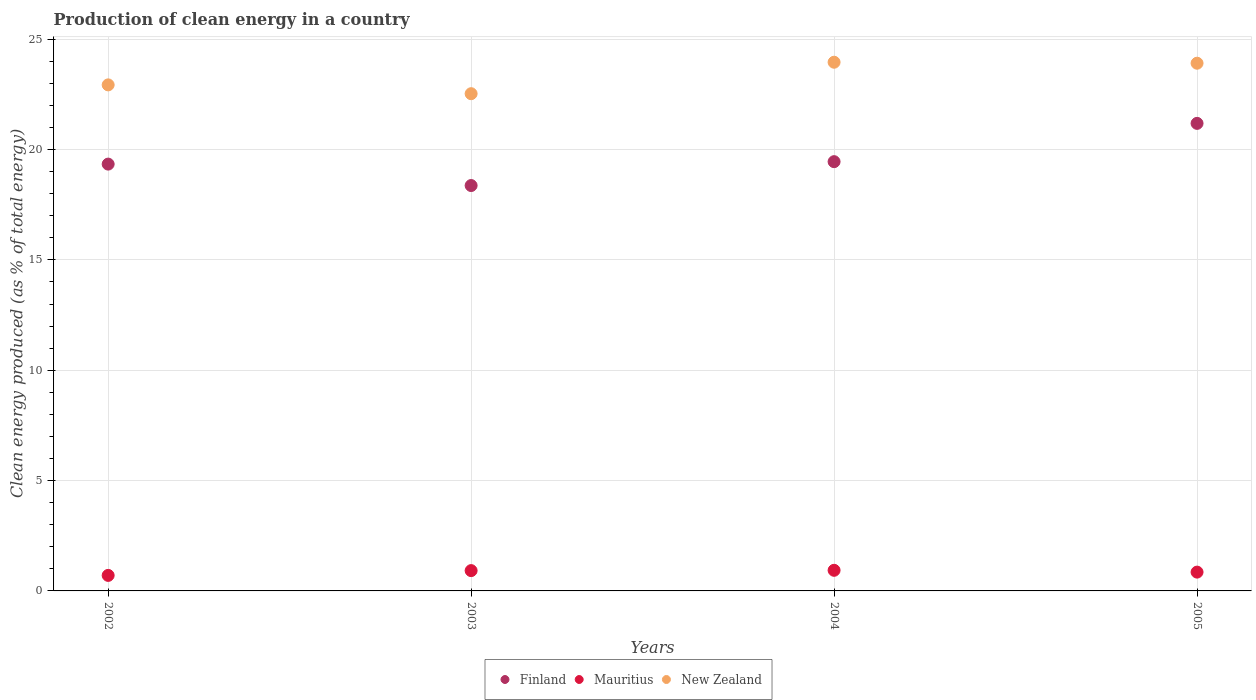How many different coloured dotlines are there?
Your answer should be very brief. 3. Is the number of dotlines equal to the number of legend labels?
Offer a very short reply. Yes. What is the percentage of clean energy produced in New Zealand in 2002?
Keep it short and to the point. 22.93. Across all years, what is the maximum percentage of clean energy produced in Finland?
Your answer should be compact. 21.19. Across all years, what is the minimum percentage of clean energy produced in Finland?
Make the answer very short. 18.37. In which year was the percentage of clean energy produced in Finland minimum?
Offer a very short reply. 2003. What is the total percentage of clean energy produced in Finland in the graph?
Your answer should be very brief. 78.35. What is the difference between the percentage of clean energy produced in New Zealand in 2003 and that in 2004?
Provide a succinct answer. -1.43. What is the difference between the percentage of clean energy produced in Mauritius in 2004 and the percentage of clean energy produced in New Zealand in 2002?
Provide a succinct answer. -22. What is the average percentage of clean energy produced in Finland per year?
Provide a short and direct response. 19.59. In the year 2004, what is the difference between the percentage of clean energy produced in Mauritius and percentage of clean energy produced in New Zealand?
Ensure brevity in your answer.  -23.02. What is the ratio of the percentage of clean energy produced in Finland in 2003 to that in 2005?
Keep it short and to the point. 0.87. Is the difference between the percentage of clean energy produced in Mauritius in 2003 and 2005 greater than the difference between the percentage of clean energy produced in New Zealand in 2003 and 2005?
Provide a succinct answer. Yes. What is the difference between the highest and the second highest percentage of clean energy produced in New Zealand?
Provide a succinct answer. 0.04. What is the difference between the highest and the lowest percentage of clean energy produced in New Zealand?
Your answer should be compact. 1.43. Is the sum of the percentage of clean energy produced in New Zealand in 2002 and 2003 greater than the maximum percentage of clean energy produced in Finland across all years?
Offer a terse response. Yes. Is it the case that in every year, the sum of the percentage of clean energy produced in New Zealand and percentage of clean energy produced in Mauritius  is greater than the percentage of clean energy produced in Finland?
Keep it short and to the point. Yes. Does the percentage of clean energy produced in Finland monotonically increase over the years?
Make the answer very short. No. Is the percentage of clean energy produced in New Zealand strictly greater than the percentage of clean energy produced in Finland over the years?
Keep it short and to the point. Yes. How many years are there in the graph?
Make the answer very short. 4. What is the difference between two consecutive major ticks on the Y-axis?
Your answer should be compact. 5. Where does the legend appear in the graph?
Keep it short and to the point. Bottom center. How are the legend labels stacked?
Offer a very short reply. Horizontal. What is the title of the graph?
Your response must be concise. Production of clean energy in a country. What is the label or title of the Y-axis?
Your response must be concise. Clean energy produced (as % of total energy). What is the Clean energy produced (as % of total energy) of Finland in 2002?
Give a very brief answer. 19.34. What is the Clean energy produced (as % of total energy) in Mauritius in 2002?
Provide a succinct answer. 0.7. What is the Clean energy produced (as % of total energy) in New Zealand in 2002?
Your response must be concise. 22.93. What is the Clean energy produced (as % of total energy) in Finland in 2003?
Your answer should be very brief. 18.37. What is the Clean energy produced (as % of total energy) in Mauritius in 2003?
Offer a terse response. 0.92. What is the Clean energy produced (as % of total energy) of New Zealand in 2003?
Give a very brief answer. 22.53. What is the Clean energy produced (as % of total energy) of Finland in 2004?
Keep it short and to the point. 19.45. What is the Clean energy produced (as % of total energy) in Mauritius in 2004?
Your answer should be compact. 0.93. What is the Clean energy produced (as % of total energy) in New Zealand in 2004?
Offer a very short reply. 23.96. What is the Clean energy produced (as % of total energy) of Finland in 2005?
Your answer should be very brief. 21.19. What is the Clean energy produced (as % of total energy) of Mauritius in 2005?
Your response must be concise. 0.85. What is the Clean energy produced (as % of total energy) of New Zealand in 2005?
Provide a succinct answer. 23.91. Across all years, what is the maximum Clean energy produced (as % of total energy) in Finland?
Offer a terse response. 21.19. Across all years, what is the maximum Clean energy produced (as % of total energy) of Mauritius?
Offer a terse response. 0.93. Across all years, what is the maximum Clean energy produced (as % of total energy) of New Zealand?
Ensure brevity in your answer.  23.96. Across all years, what is the minimum Clean energy produced (as % of total energy) in Finland?
Provide a short and direct response. 18.37. Across all years, what is the minimum Clean energy produced (as % of total energy) of Mauritius?
Your answer should be compact. 0.7. Across all years, what is the minimum Clean energy produced (as % of total energy) of New Zealand?
Ensure brevity in your answer.  22.53. What is the total Clean energy produced (as % of total energy) in Finland in the graph?
Offer a terse response. 78.35. What is the total Clean energy produced (as % of total energy) in Mauritius in the graph?
Give a very brief answer. 3.41. What is the total Clean energy produced (as % of total energy) of New Zealand in the graph?
Provide a short and direct response. 93.33. What is the difference between the Clean energy produced (as % of total energy) in Finland in 2002 and that in 2003?
Make the answer very short. 0.97. What is the difference between the Clean energy produced (as % of total energy) of Mauritius in 2002 and that in 2003?
Offer a very short reply. -0.22. What is the difference between the Clean energy produced (as % of total energy) in New Zealand in 2002 and that in 2003?
Your answer should be very brief. 0.4. What is the difference between the Clean energy produced (as % of total energy) of Finland in 2002 and that in 2004?
Provide a short and direct response. -0.11. What is the difference between the Clean energy produced (as % of total energy) of Mauritius in 2002 and that in 2004?
Provide a succinct answer. -0.23. What is the difference between the Clean energy produced (as % of total energy) in New Zealand in 2002 and that in 2004?
Give a very brief answer. -1.03. What is the difference between the Clean energy produced (as % of total energy) in Finland in 2002 and that in 2005?
Provide a succinct answer. -1.85. What is the difference between the Clean energy produced (as % of total energy) of Mauritius in 2002 and that in 2005?
Keep it short and to the point. -0.15. What is the difference between the Clean energy produced (as % of total energy) in New Zealand in 2002 and that in 2005?
Ensure brevity in your answer.  -0.98. What is the difference between the Clean energy produced (as % of total energy) in Finland in 2003 and that in 2004?
Provide a short and direct response. -1.08. What is the difference between the Clean energy produced (as % of total energy) of Mauritius in 2003 and that in 2004?
Your answer should be very brief. -0.01. What is the difference between the Clean energy produced (as % of total energy) of New Zealand in 2003 and that in 2004?
Make the answer very short. -1.43. What is the difference between the Clean energy produced (as % of total energy) in Finland in 2003 and that in 2005?
Give a very brief answer. -2.82. What is the difference between the Clean energy produced (as % of total energy) of Mauritius in 2003 and that in 2005?
Your response must be concise. 0.07. What is the difference between the Clean energy produced (as % of total energy) of New Zealand in 2003 and that in 2005?
Your answer should be very brief. -1.38. What is the difference between the Clean energy produced (as % of total energy) in Finland in 2004 and that in 2005?
Provide a short and direct response. -1.74. What is the difference between the Clean energy produced (as % of total energy) in Mauritius in 2004 and that in 2005?
Provide a short and direct response. 0.08. What is the difference between the Clean energy produced (as % of total energy) in New Zealand in 2004 and that in 2005?
Provide a short and direct response. 0.04. What is the difference between the Clean energy produced (as % of total energy) in Finland in 2002 and the Clean energy produced (as % of total energy) in Mauritius in 2003?
Ensure brevity in your answer.  18.42. What is the difference between the Clean energy produced (as % of total energy) of Finland in 2002 and the Clean energy produced (as % of total energy) of New Zealand in 2003?
Keep it short and to the point. -3.19. What is the difference between the Clean energy produced (as % of total energy) of Mauritius in 2002 and the Clean energy produced (as % of total energy) of New Zealand in 2003?
Your answer should be compact. -21.83. What is the difference between the Clean energy produced (as % of total energy) in Finland in 2002 and the Clean energy produced (as % of total energy) in Mauritius in 2004?
Your answer should be very brief. 18.41. What is the difference between the Clean energy produced (as % of total energy) in Finland in 2002 and the Clean energy produced (as % of total energy) in New Zealand in 2004?
Offer a terse response. -4.62. What is the difference between the Clean energy produced (as % of total energy) in Mauritius in 2002 and the Clean energy produced (as % of total energy) in New Zealand in 2004?
Your response must be concise. -23.25. What is the difference between the Clean energy produced (as % of total energy) in Finland in 2002 and the Clean energy produced (as % of total energy) in Mauritius in 2005?
Provide a short and direct response. 18.49. What is the difference between the Clean energy produced (as % of total energy) of Finland in 2002 and the Clean energy produced (as % of total energy) of New Zealand in 2005?
Give a very brief answer. -4.57. What is the difference between the Clean energy produced (as % of total energy) in Mauritius in 2002 and the Clean energy produced (as % of total energy) in New Zealand in 2005?
Your answer should be very brief. -23.21. What is the difference between the Clean energy produced (as % of total energy) in Finland in 2003 and the Clean energy produced (as % of total energy) in Mauritius in 2004?
Your response must be concise. 17.43. What is the difference between the Clean energy produced (as % of total energy) in Finland in 2003 and the Clean energy produced (as % of total energy) in New Zealand in 2004?
Provide a succinct answer. -5.59. What is the difference between the Clean energy produced (as % of total energy) in Mauritius in 2003 and the Clean energy produced (as % of total energy) in New Zealand in 2004?
Provide a short and direct response. -23.04. What is the difference between the Clean energy produced (as % of total energy) in Finland in 2003 and the Clean energy produced (as % of total energy) in Mauritius in 2005?
Keep it short and to the point. 17.52. What is the difference between the Clean energy produced (as % of total energy) of Finland in 2003 and the Clean energy produced (as % of total energy) of New Zealand in 2005?
Provide a succinct answer. -5.54. What is the difference between the Clean energy produced (as % of total energy) in Mauritius in 2003 and the Clean energy produced (as % of total energy) in New Zealand in 2005?
Your answer should be very brief. -22.99. What is the difference between the Clean energy produced (as % of total energy) of Finland in 2004 and the Clean energy produced (as % of total energy) of Mauritius in 2005?
Give a very brief answer. 18.6. What is the difference between the Clean energy produced (as % of total energy) in Finland in 2004 and the Clean energy produced (as % of total energy) in New Zealand in 2005?
Give a very brief answer. -4.46. What is the difference between the Clean energy produced (as % of total energy) in Mauritius in 2004 and the Clean energy produced (as % of total energy) in New Zealand in 2005?
Offer a very short reply. -22.98. What is the average Clean energy produced (as % of total energy) in Finland per year?
Your answer should be compact. 19.59. What is the average Clean energy produced (as % of total energy) of Mauritius per year?
Give a very brief answer. 0.85. What is the average Clean energy produced (as % of total energy) of New Zealand per year?
Your response must be concise. 23.33. In the year 2002, what is the difference between the Clean energy produced (as % of total energy) of Finland and Clean energy produced (as % of total energy) of Mauritius?
Your response must be concise. 18.64. In the year 2002, what is the difference between the Clean energy produced (as % of total energy) in Finland and Clean energy produced (as % of total energy) in New Zealand?
Provide a succinct answer. -3.59. In the year 2002, what is the difference between the Clean energy produced (as % of total energy) of Mauritius and Clean energy produced (as % of total energy) of New Zealand?
Your response must be concise. -22.23. In the year 2003, what is the difference between the Clean energy produced (as % of total energy) in Finland and Clean energy produced (as % of total energy) in Mauritius?
Make the answer very short. 17.45. In the year 2003, what is the difference between the Clean energy produced (as % of total energy) of Finland and Clean energy produced (as % of total energy) of New Zealand?
Keep it short and to the point. -4.16. In the year 2003, what is the difference between the Clean energy produced (as % of total energy) in Mauritius and Clean energy produced (as % of total energy) in New Zealand?
Give a very brief answer. -21.61. In the year 2004, what is the difference between the Clean energy produced (as % of total energy) of Finland and Clean energy produced (as % of total energy) of Mauritius?
Offer a terse response. 18.52. In the year 2004, what is the difference between the Clean energy produced (as % of total energy) in Finland and Clean energy produced (as % of total energy) in New Zealand?
Offer a very short reply. -4.51. In the year 2004, what is the difference between the Clean energy produced (as % of total energy) of Mauritius and Clean energy produced (as % of total energy) of New Zealand?
Your answer should be compact. -23.02. In the year 2005, what is the difference between the Clean energy produced (as % of total energy) of Finland and Clean energy produced (as % of total energy) of Mauritius?
Provide a succinct answer. 20.33. In the year 2005, what is the difference between the Clean energy produced (as % of total energy) in Finland and Clean energy produced (as % of total energy) in New Zealand?
Keep it short and to the point. -2.73. In the year 2005, what is the difference between the Clean energy produced (as % of total energy) in Mauritius and Clean energy produced (as % of total energy) in New Zealand?
Provide a short and direct response. -23.06. What is the ratio of the Clean energy produced (as % of total energy) in Finland in 2002 to that in 2003?
Your answer should be compact. 1.05. What is the ratio of the Clean energy produced (as % of total energy) of Mauritius in 2002 to that in 2003?
Your answer should be very brief. 0.76. What is the ratio of the Clean energy produced (as % of total energy) in New Zealand in 2002 to that in 2003?
Provide a succinct answer. 1.02. What is the ratio of the Clean energy produced (as % of total energy) of Mauritius in 2002 to that in 2004?
Keep it short and to the point. 0.75. What is the ratio of the Clean energy produced (as % of total energy) in New Zealand in 2002 to that in 2004?
Offer a terse response. 0.96. What is the ratio of the Clean energy produced (as % of total energy) of Finland in 2002 to that in 2005?
Offer a terse response. 0.91. What is the ratio of the Clean energy produced (as % of total energy) in Mauritius in 2002 to that in 2005?
Offer a very short reply. 0.83. What is the ratio of the Clean energy produced (as % of total energy) in New Zealand in 2002 to that in 2005?
Ensure brevity in your answer.  0.96. What is the ratio of the Clean energy produced (as % of total energy) of New Zealand in 2003 to that in 2004?
Your answer should be compact. 0.94. What is the ratio of the Clean energy produced (as % of total energy) in Finland in 2003 to that in 2005?
Give a very brief answer. 0.87. What is the ratio of the Clean energy produced (as % of total energy) of Mauritius in 2003 to that in 2005?
Provide a succinct answer. 1.08. What is the ratio of the Clean energy produced (as % of total energy) in New Zealand in 2003 to that in 2005?
Give a very brief answer. 0.94. What is the ratio of the Clean energy produced (as % of total energy) in Finland in 2004 to that in 2005?
Your answer should be compact. 0.92. What is the ratio of the Clean energy produced (as % of total energy) of Mauritius in 2004 to that in 2005?
Keep it short and to the point. 1.1. What is the ratio of the Clean energy produced (as % of total energy) of New Zealand in 2004 to that in 2005?
Your answer should be very brief. 1. What is the difference between the highest and the second highest Clean energy produced (as % of total energy) in Finland?
Your answer should be compact. 1.74. What is the difference between the highest and the second highest Clean energy produced (as % of total energy) of Mauritius?
Give a very brief answer. 0.01. What is the difference between the highest and the second highest Clean energy produced (as % of total energy) in New Zealand?
Provide a succinct answer. 0.04. What is the difference between the highest and the lowest Clean energy produced (as % of total energy) of Finland?
Offer a terse response. 2.82. What is the difference between the highest and the lowest Clean energy produced (as % of total energy) of Mauritius?
Keep it short and to the point. 0.23. What is the difference between the highest and the lowest Clean energy produced (as % of total energy) in New Zealand?
Make the answer very short. 1.43. 